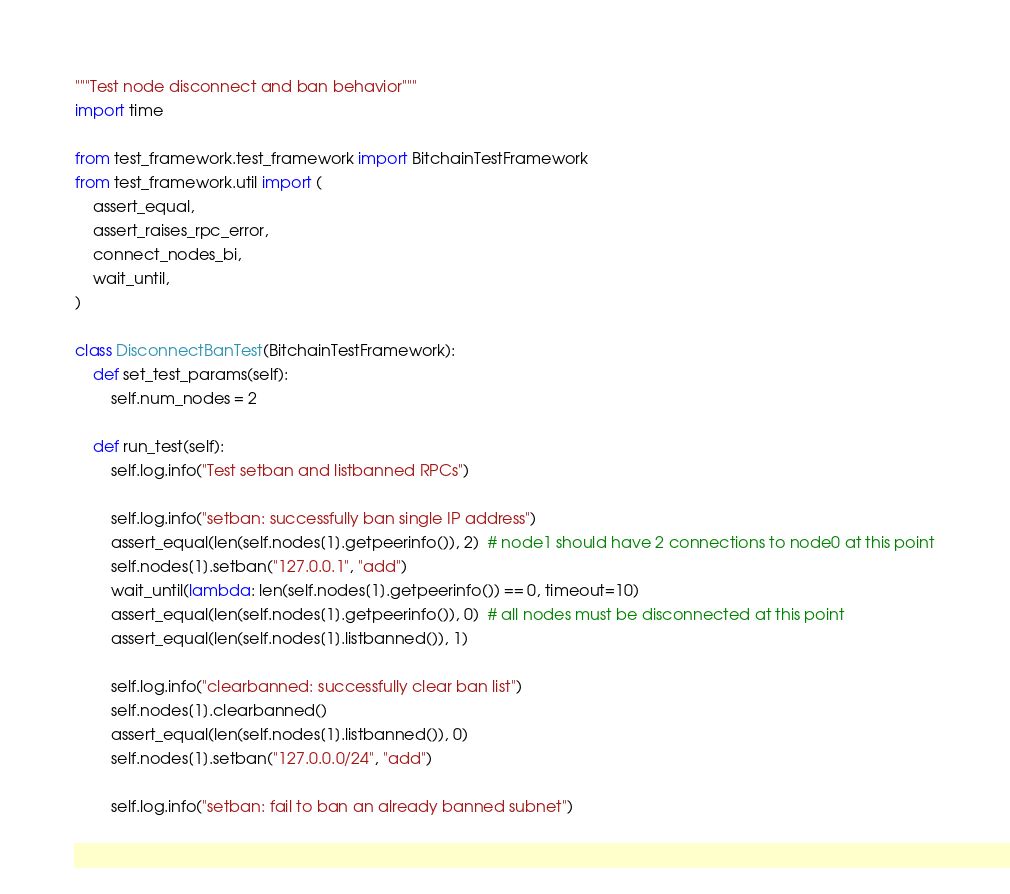<code> <loc_0><loc_0><loc_500><loc_500><_Python_>"""Test node disconnect and ban behavior"""
import time

from test_framework.test_framework import BitchainTestFramework
from test_framework.util import (
    assert_equal,
    assert_raises_rpc_error,
    connect_nodes_bi,
    wait_until,
)

class DisconnectBanTest(BitchainTestFramework):
    def set_test_params(self):
        self.num_nodes = 2

    def run_test(self):
        self.log.info("Test setban and listbanned RPCs")

        self.log.info("setban: successfully ban single IP address")
        assert_equal(len(self.nodes[1].getpeerinfo()), 2)  # node1 should have 2 connections to node0 at this point
        self.nodes[1].setban("127.0.0.1", "add")
        wait_until(lambda: len(self.nodes[1].getpeerinfo()) == 0, timeout=10)
        assert_equal(len(self.nodes[1].getpeerinfo()), 0)  # all nodes must be disconnected at this point
        assert_equal(len(self.nodes[1].listbanned()), 1)

        self.log.info("clearbanned: successfully clear ban list")
        self.nodes[1].clearbanned()
        assert_equal(len(self.nodes[1].listbanned()), 0)
        self.nodes[1].setban("127.0.0.0/24", "add")

        self.log.info("setban: fail to ban an already banned subnet")</code> 